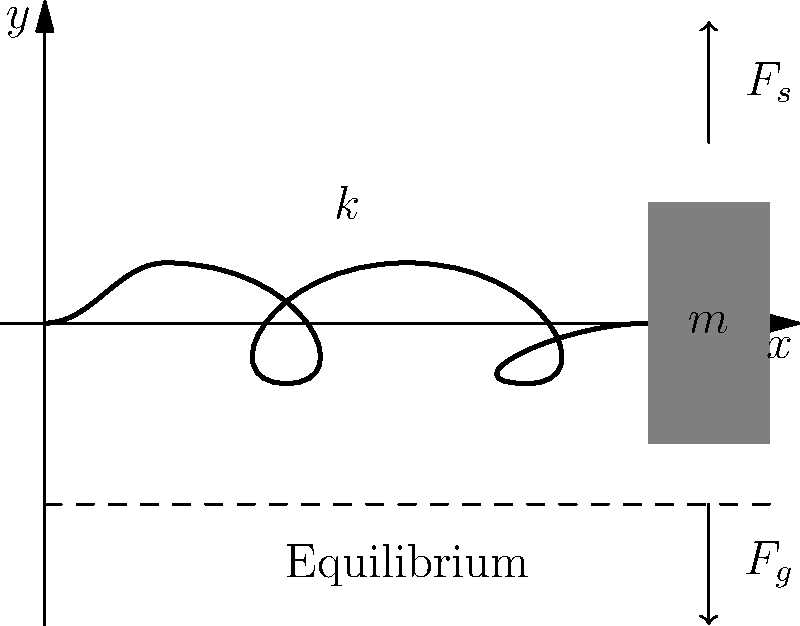As a successful entrepreneur who values practical applications, consider a mass-spring system in simple harmonic motion. The spring constant is $k = 100$ N/m, and the mass is $m = 2$ kg. If the system is displaced 0.1 m from its equilibrium position, what is the maximum acceleration experienced by the mass? How might understanding this concept relate to developing innovative suspension systems for vehicles? Let's approach this step-by-step:

1) In simple harmonic motion, the maximum acceleration occurs at the equilibrium position when the displacement is zero.

2) The equation for acceleration in SHM is:
   $$a = -\omega^2 x$$
   where $\omega$ is the angular frequency and $x$ is the displacement.

3) The maximum acceleration magnitude is:
   $$a_{max} = \omega^2 A$$
   where $A$ is the amplitude (maximum displacement).

4) We need to find $\omega$. For a mass-spring system:
   $$\omega = \sqrt{\frac{k}{m}}$$

5) Substituting the given values:
   $$\omega = \sqrt{\frac{100 \text{ N/m}}{2 \text{ kg}}} = 7.07 \text{ rad/s}$$

6) Now we can calculate the maximum acceleration:
   $$a_{max} = (7.07 \text{ rad/s})^2 \times 0.1 \text{ m} = 5 \text{ m/s}^2$$

Understanding this concept is crucial for developing innovative suspension systems. It helps in designing systems that can absorb shocks and vibrations effectively, improving ride comfort and vehicle stability. This knowledge can be applied to create adaptive suspension systems that adjust based on road conditions, enhancing both performance and comfort in vehicles.
Answer: 5 m/s² 